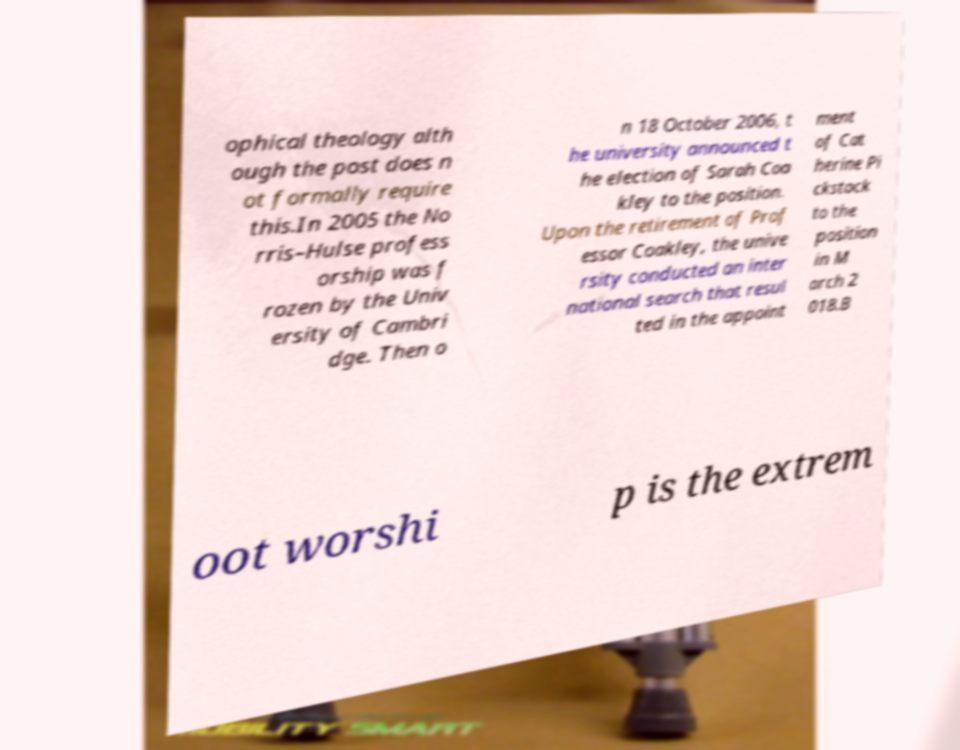Could you extract and type out the text from this image? ophical theology alth ough the post does n ot formally require this.In 2005 the No rris–Hulse profess orship was f rozen by the Univ ersity of Cambri dge. Then o n 18 October 2006, t he university announced t he election of Sarah Coa kley to the position. Upon the retirement of Prof essor Coakley, the unive rsity conducted an inter national search that resul ted in the appoint ment of Cat herine Pi ckstock to the position in M arch 2 018.B oot worshi p is the extrem 